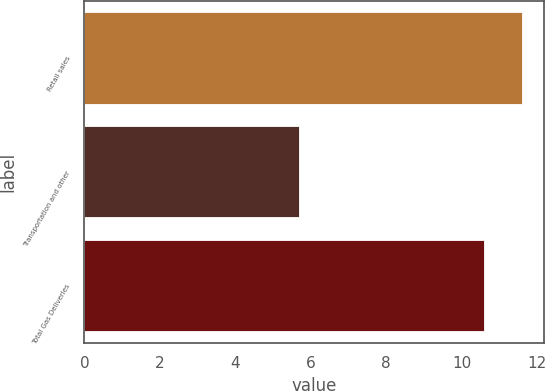Convert chart to OTSL. <chart><loc_0><loc_0><loc_500><loc_500><bar_chart><fcel>Retail sales<fcel>Transportation and other<fcel>Total Gas Deliveries<nl><fcel>11.6<fcel>5.7<fcel>10.6<nl></chart> 